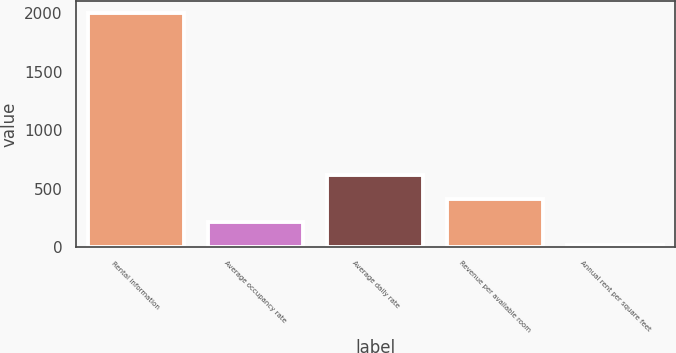Convert chart. <chart><loc_0><loc_0><loc_500><loc_500><bar_chart><fcel>Rental information<fcel>Average occupancy rate<fcel>Average daily rate<fcel>Revenue per available room<fcel>Annual rent per square feet<nl><fcel>2006<fcel>215.38<fcel>613.3<fcel>414.34<fcel>16.42<nl></chart> 